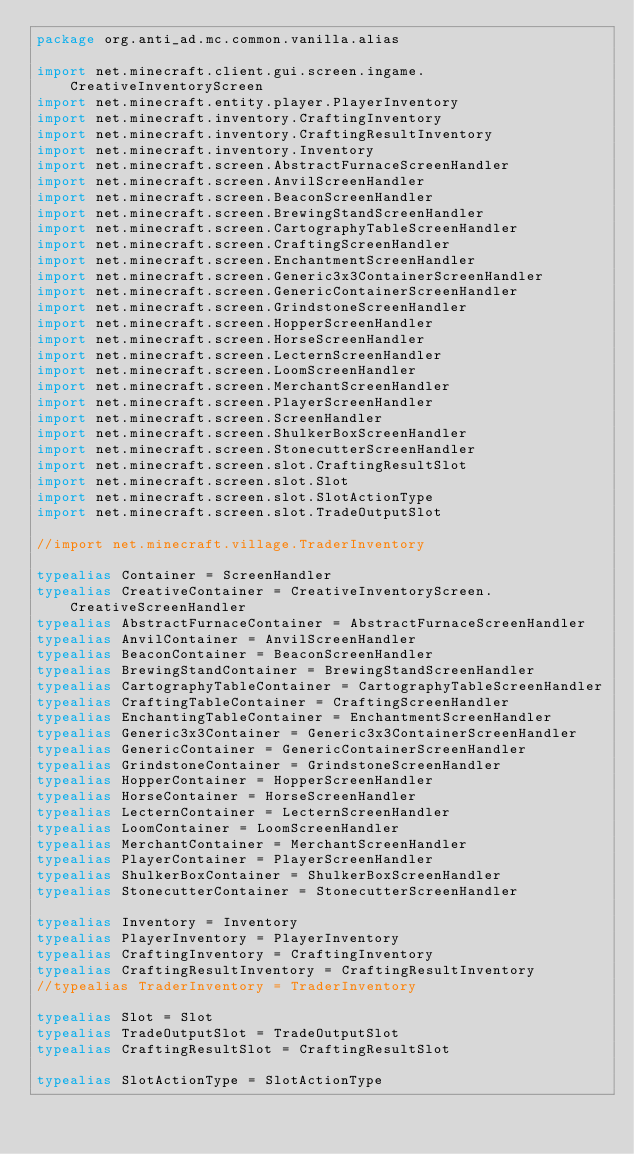<code> <loc_0><loc_0><loc_500><loc_500><_Kotlin_>package org.anti_ad.mc.common.vanilla.alias

import net.minecraft.client.gui.screen.ingame.CreativeInventoryScreen
import net.minecraft.entity.player.PlayerInventory
import net.minecraft.inventory.CraftingInventory
import net.minecraft.inventory.CraftingResultInventory
import net.minecraft.inventory.Inventory
import net.minecraft.screen.AbstractFurnaceScreenHandler
import net.minecraft.screen.AnvilScreenHandler
import net.minecraft.screen.BeaconScreenHandler
import net.minecraft.screen.BrewingStandScreenHandler
import net.minecraft.screen.CartographyTableScreenHandler
import net.minecraft.screen.CraftingScreenHandler
import net.minecraft.screen.EnchantmentScreenHandler
import net.minecraft.screen.Generic3x3ContainerScreenHandler
import net.minecraft.screen.GenericContainerScreenHandler
import net.minecraft.screen.GrindstoneScreenHandler
import net.minecraft.screen.HopperScreenHandler
import net.minecraft.screen.HorseScreenHandler
import net.minecraft.screen.LecternScreenHandler
import net.minecraft.screen.LoomScreenHandler
import net.minecraft.screen.MerchantScreenHandler
import net.minecraft.screen.PlayerScreenHandler
import net.minecraft.screen.ScreenHandler
import net.minecraft.screen.ShulkerBoxScreenHandler
import net.minecraft.screen.StonecutterScreenHandler
import net.minecraft.screen.slot.CraftingResultSlot
import net.minecraft.screen.slot.Slot
import net.minecraft.screen.slot.SlotActionType
import net.minecraft.screen.slot.TradeOutputSlot

//import net.minecraft.village.TraderInventory

typealias Container = ScreenHandler
typealias CreativeContainer = CreativeInventoryScreen.CreativeScreenHandler
typealias AbstractFurnaceContainer = AbstractFurnaceScreenHandler
typealias AnvilContainer = AnvilScreenHandler
typealias BeaconContainer = BeaconScreenHandler
typealias BrewingStandContainer = BrewingStandScreenHandler
typealias CartographyTableContainer = CartographyTableScreenHandler
typealias CraftingTableContainer = CraftingScreenHandler
typealias EnchantingTableContainer = EnchantmentScreenHandler
typealias Generic3x3Container = Generic3x3ContainerScreenHandler
typealias GenericContainer = GenericContainerScreenHandler
typealias GrindstoneContainer = GrindstoneScreenHandler
typealias HopperContainer = HopperScreenHandler
typealias HorseContainer = HorseScreenHandler
typealias LecternContainer = LecternScreenHandler
typealias LoomContainer = LoomScreenHandler
typealias MerchantContainer = MerchantScreenHandler
typealias PlayerContainer = PlayerScreenHandler
typealias ShulkerBoxContainer = ShulkerBoxScreenHandler
typealias StonecutterContainer = StonecutterScreenHandler

typealias Inventory = Inventory
typealias PlayerInventory = PlayerInventory
typealias CraftingInventory = CraftingInventory
typealias CraftingResultInventory = CraftingResultInventory
//typealias TraderInventory = TraderInventory

typealias Slot = Slot
typealias TradeOutputSlot = TradeOutputSlot
typealias CraftingResultSlot = CraftingResultSlot

typealias SlotActionType = SlotActionType
</code> 